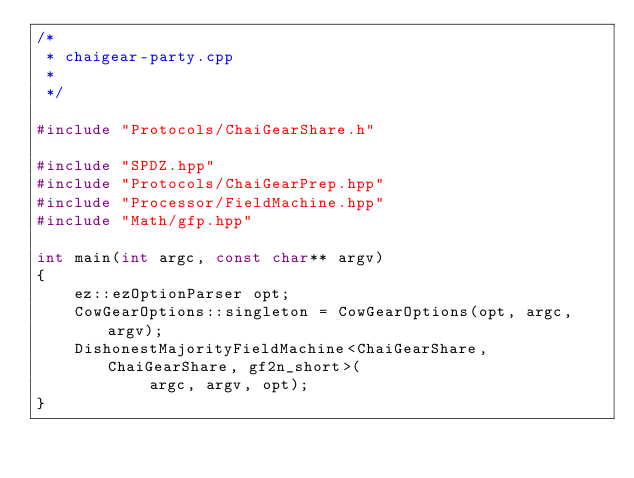Convert code to text. <code><loc_0><loc_0><loc_500><loc_500><_C++_>/*
 * chaigear-party.cpp
 *
 */

#include "Protocols/ChaiGearShare.h"

#include "SPDZ.hpp"
#include "Protocols/ChaiGearPrep.hpp"
#include "Processor/FieldMachine.hpp"
#include "Math/gfp.hpp"

int main(int argc, const char** argv)
{
    ez::ezOptionParser opt;
    CowGearOptions::singleton = CowGearOptions(opt, argc, argv);
    DishonestMajorityFieldMachine<ChaiGearShare, ChaiGearShare, gf2n_short>(
            argc, argv, opt);
}
</code> 